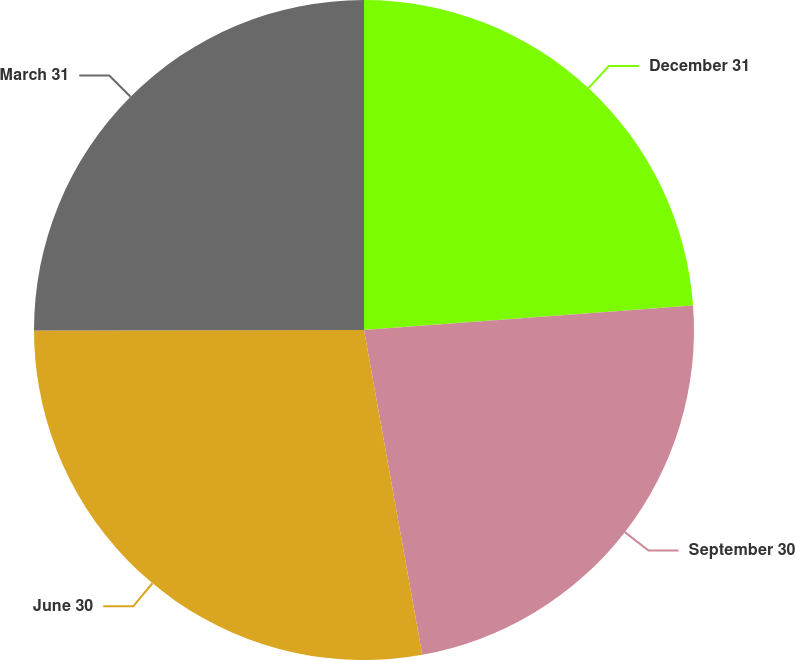<chart> <loc_0><loc_0><loc_500><loc_500><pie_chart><fcel>December 31<fcel>September 30<fcel>June 30<fcel>March 31<nl><fcel>23.81%<fcel>23.36%<fcel>27.8%<fcel>25.02%<nl></chart> 